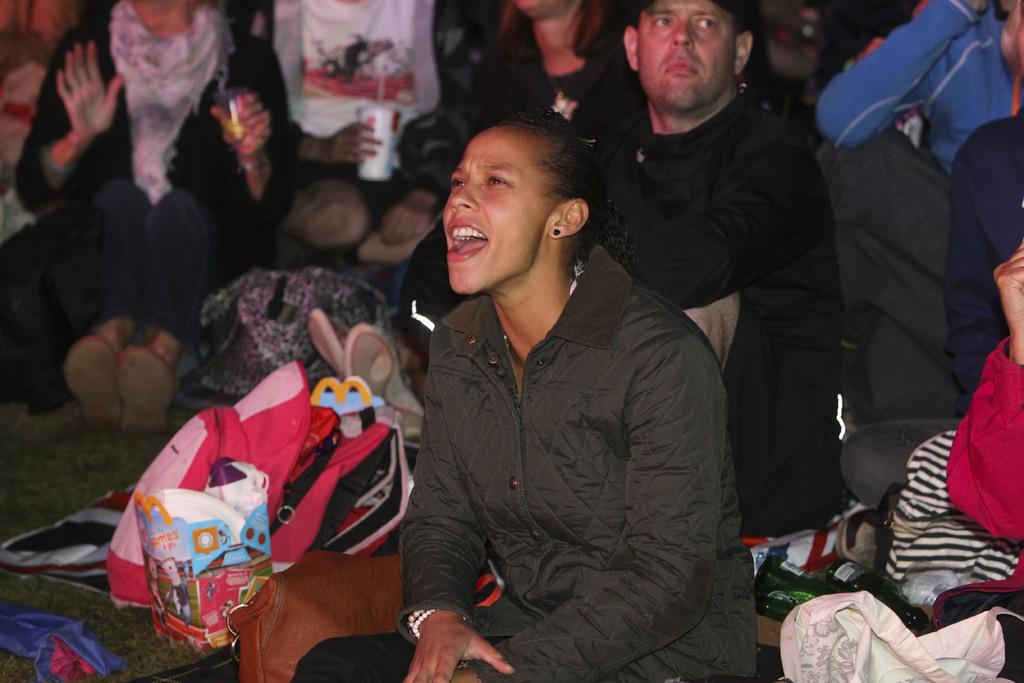How many people are in the group in the image? There is a group of persons in the image, but the exact number cannot be determined from the provided facts. What are some of the persons in the group doing? Some persons in the group are holding objects. What can be seen in front of the persons in the image? There are bags, bottles, and other objects visible in front of the persons. What type of meat is being cooked by the toad in the image? There is no toad or meat present in the image. How many buns are visible in the image? The provided facts do not mention the presence of buns in the image. 